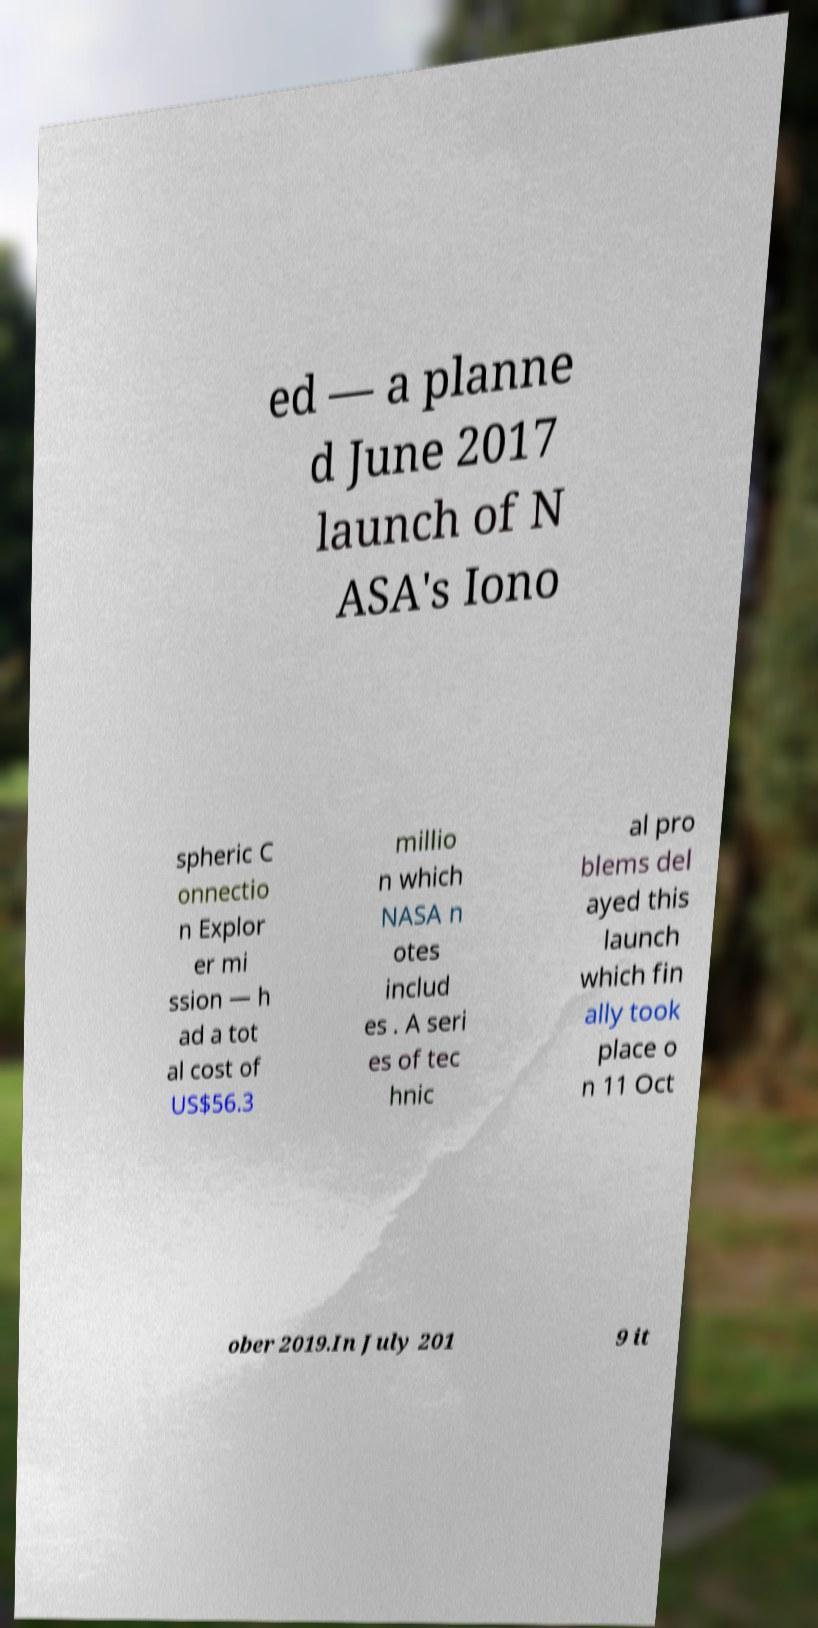I need the written content from this picture converted into text. Can you do that? ed — a planne d June 2017 launch of N ASA's Iono spheric C onnectio n Explor er mi ssion — h ad a tot al cost of US$56.3 millio n which NASA n otes includ es . A seri es of tec hnic al pro blems del ayed this launch which fin ally took place o n 11 Oct ober 2019.In July 201 9 it 